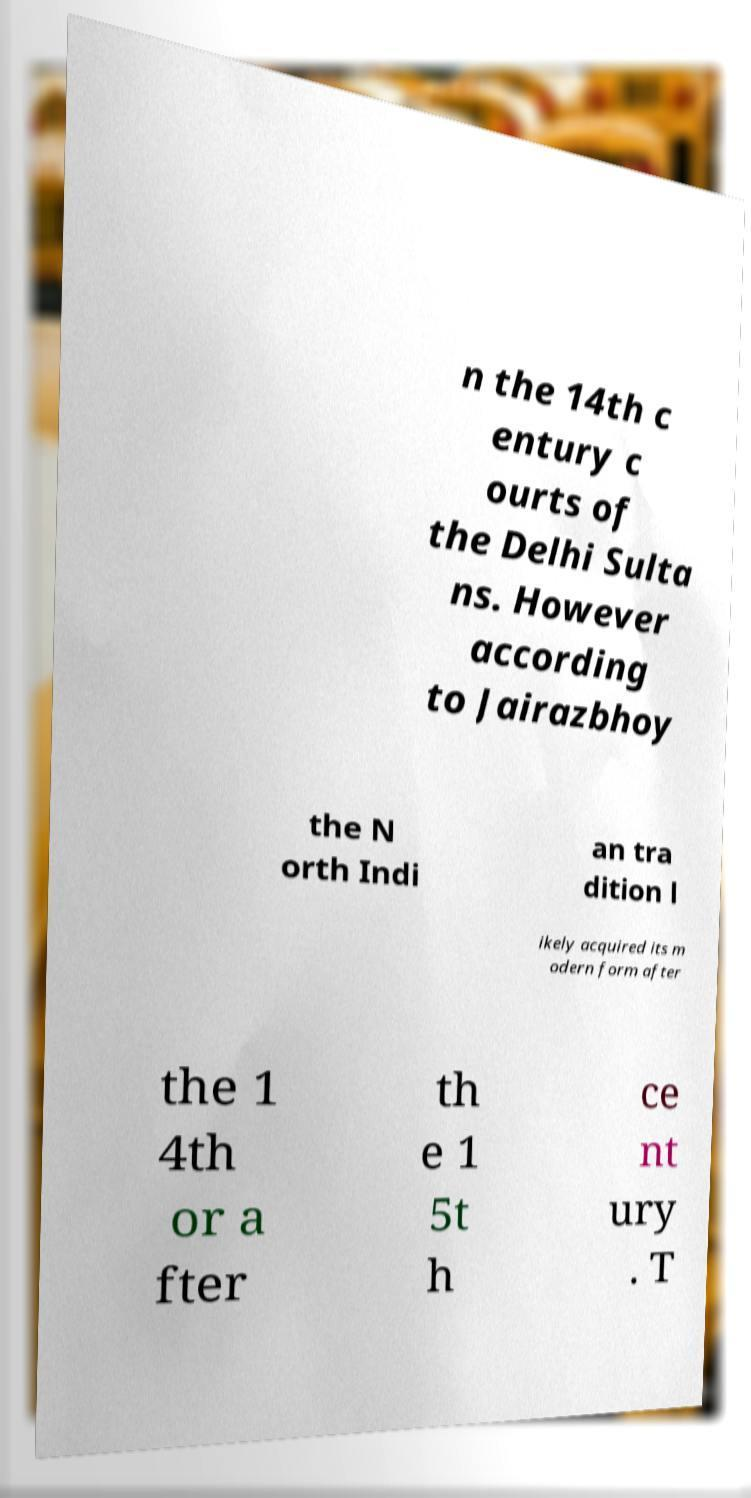What messages or text are displayed in this image? I need them in a readable, typed format. n the 14th c entury c ourts of the Delhi Sulta ns. However according to Jairazbhoy the N orth Indi an tra dition l ikely acquired its m odern form after the 1 4th or a fter th e 1 5t h ce nt ury . T 